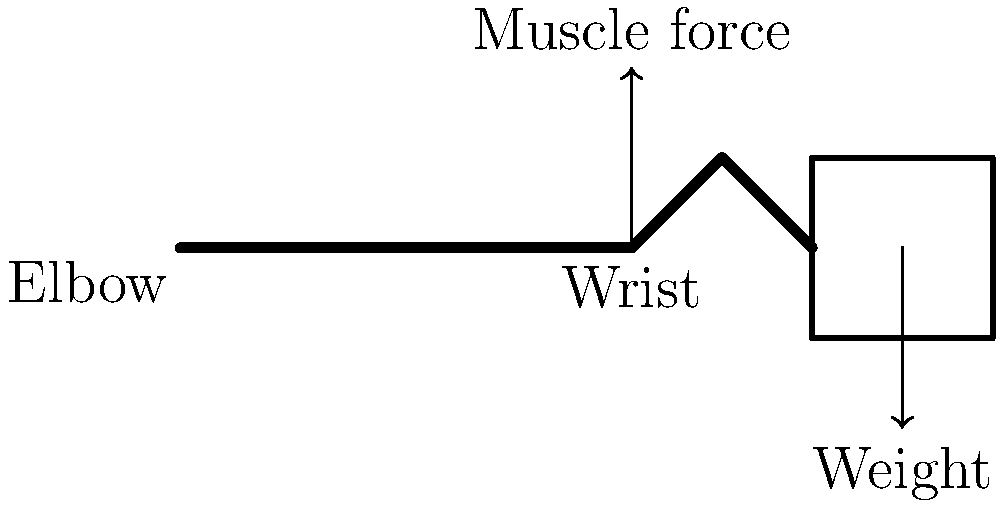When holding a camera for long exposures during sunrise or sunset photography in Brockhall, what is the primary biomechanical principle that helps maintain hand stability? To understand the biomechanics of hand stability while holding a camera for long exposures, we need to consider the following steps:

1. Force balance: The weight of the camera creates a downward force at the wrist joint.

2. Muscle activation: To counteract this force, the forearm muscles (particularly the wrist extensors) must generate an upward force.

3. Isometric contraction: These muscles maintain a constant length while generating force, known as an isometric contraction.

4. Minimizing tremor: Isometric contractions are generally more stable than dynamic contractions, helping to reduce hand tremor.

5. Co-contraction: Simultaneous activation of antagonistic muscles (flexors and extensors) increases joint stiffness and stability.

6. Proximal stabilization: Stabilizing the shoulder and elbow joints provides a stable base for the hand.

7. Proprioception: The body's sense of position and movement helps maintain the camera's position.

8. Practice and fatigue management: Regular practice improves muscle endurance and coordination, while managing fatigue is crucial for long exposures.

The primary biomechanical principle at work here is the isometric muscle contraction, which allows for sustained force production with minimal movement, crucial for maintaining stability during long exposure photography.
Answer: Isometric muscle contraction 